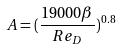<formula> <loc_0><loc_0><loc_500><loc_500>A = ( \frac { 1 9 0 0 0 \beta } { R e _ { D } } ) ^ { 0 . 8 }</formula> 